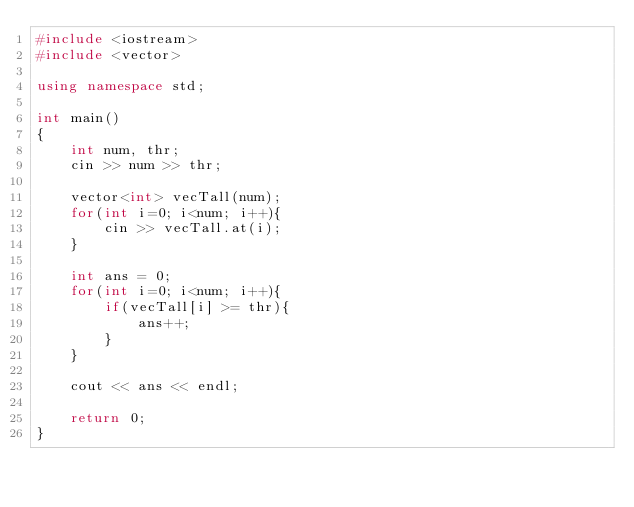<code> <loc_0><loc_0><loc_500><loc_500><_C++_>#include <iostream>
#include <vector>

using namespace std;

int main()
{
    int num, thr;
    cin >> num >> thr;

    vector<int> vecTall(num);
    for(int i=0; i<num; i++){
        cin >> vecTall.at(i);
    }
    
    int ans = 0;
    for(int i=0; i<num; i++){
        if(vecTall[i] >= thr){
            ans++;
        }
    }

    cout << ans << endl;

    return 0;
}</code> 